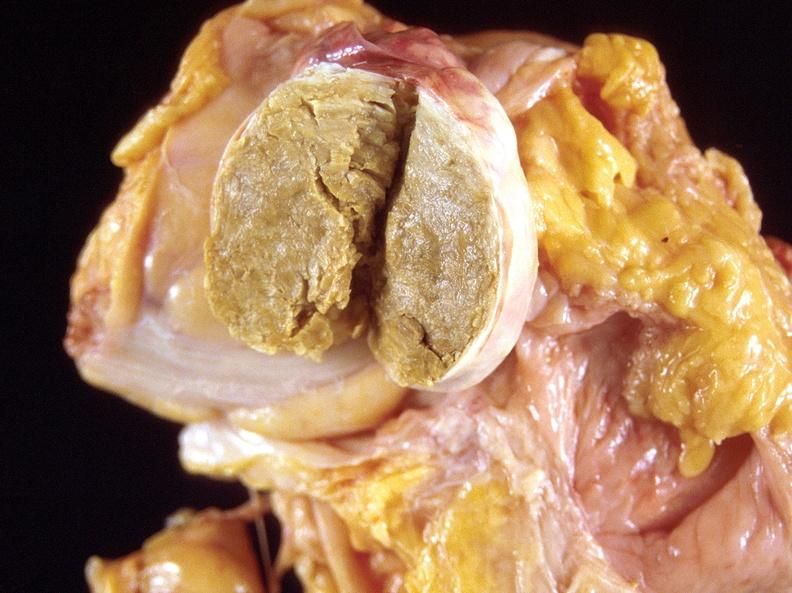does photo show dermoid cyst?
Answer the question using a single word or phrase. No 